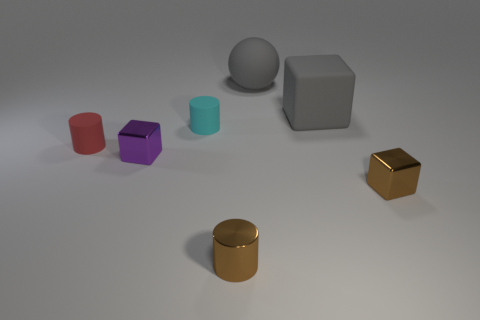There is a cube that is the same color as the matte ball; what size is it?
Your answer should be very brief. Large. What size is the metal block that is right of the matte cylinder right of the tiny red rubber cylinder that is in front of the rubber sphere?
Provide a short and direct response. Small. How big is the thing that is right of the big gray ball and to the left of the small brown cube?
Provide a succinct answer. Large. What shape is the tiny object left of the tiny block on the left side of the shiny cylinder?
Your answer should be compact. Cylinder. Is there any other thing that has the same color as the matte ball?
Your response must be concise. Yes. There is a brown thing left of the gray matte cube; what shape is it?
Make the answer very short. Cylinder. The rubber object that is both on the right side of the small purple shiny thing and on the left side of the large sphere has what shape?
Keep it short and to the point. Cylinder. What number of purple objects are either matte cubes or big things?
Make the answer very short. 0. Do the cube that is on the left side of the brown cylinder and the large block have the same color?
Provide a short and direct response. No. There is a rubber cylinder in front of the small cylinder that is behind the red matte cylinder; what is its size?
Your response must be concise. Small. 